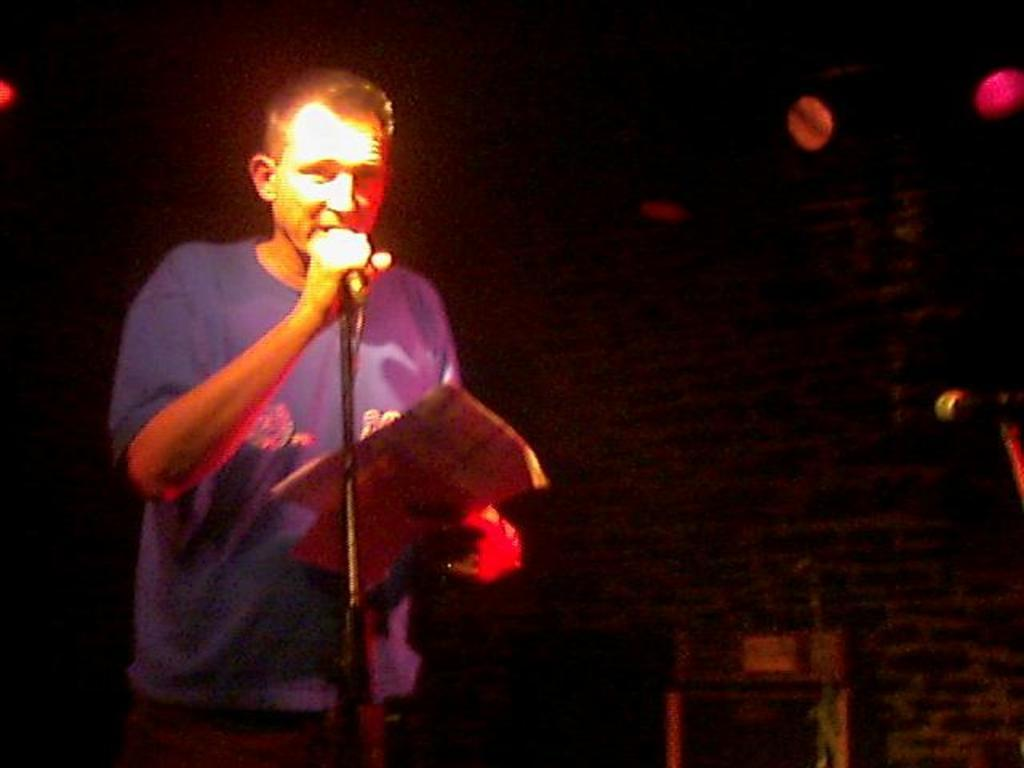What is the main subject of the image? There is a person in the image. What is the person doing in the image? The person is standing and speaking. What object is in front of the person? There is a microphone in front of the person. How is the person holding the microphone? The person is holding the microphone in his hand. What type of company is the person representing in the image? There is no information about a company in the image, so it cannot be determined. 